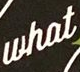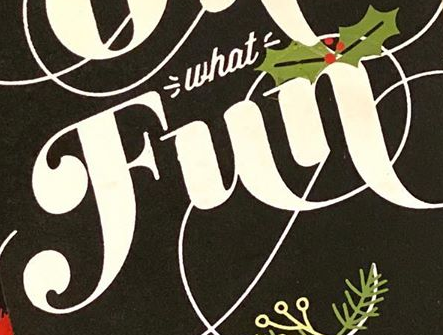Read the text from these images in sequence, separated by a semicolon. what; Fun 